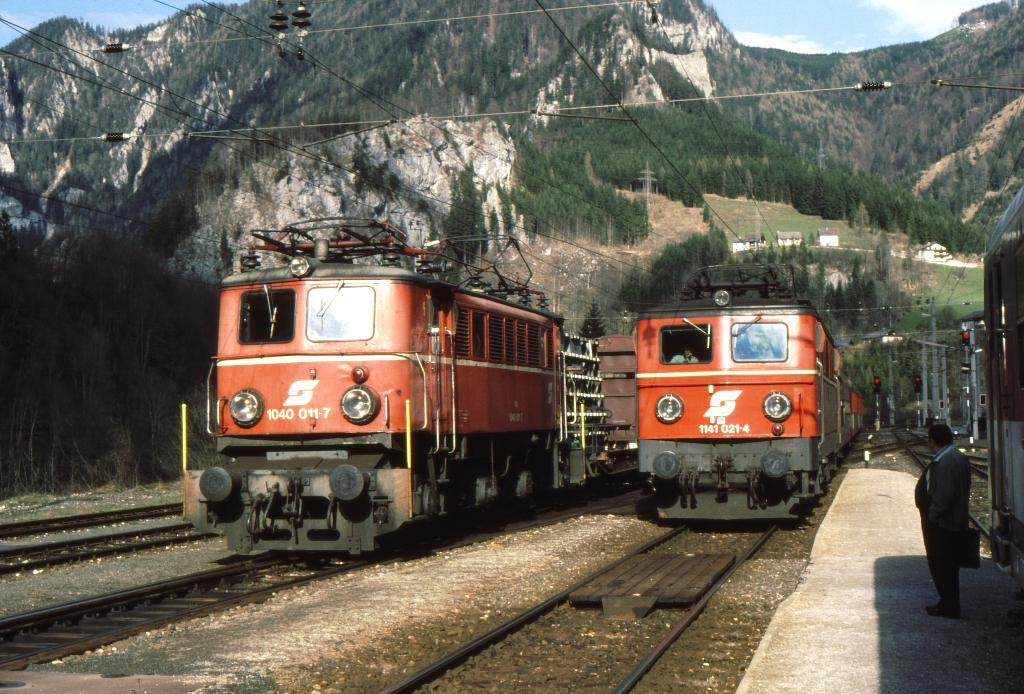<image>
Relay a brief, clear account of the picture shown. Two red trains that  have the same logo on them, the one on the right says 1141 021 4. 